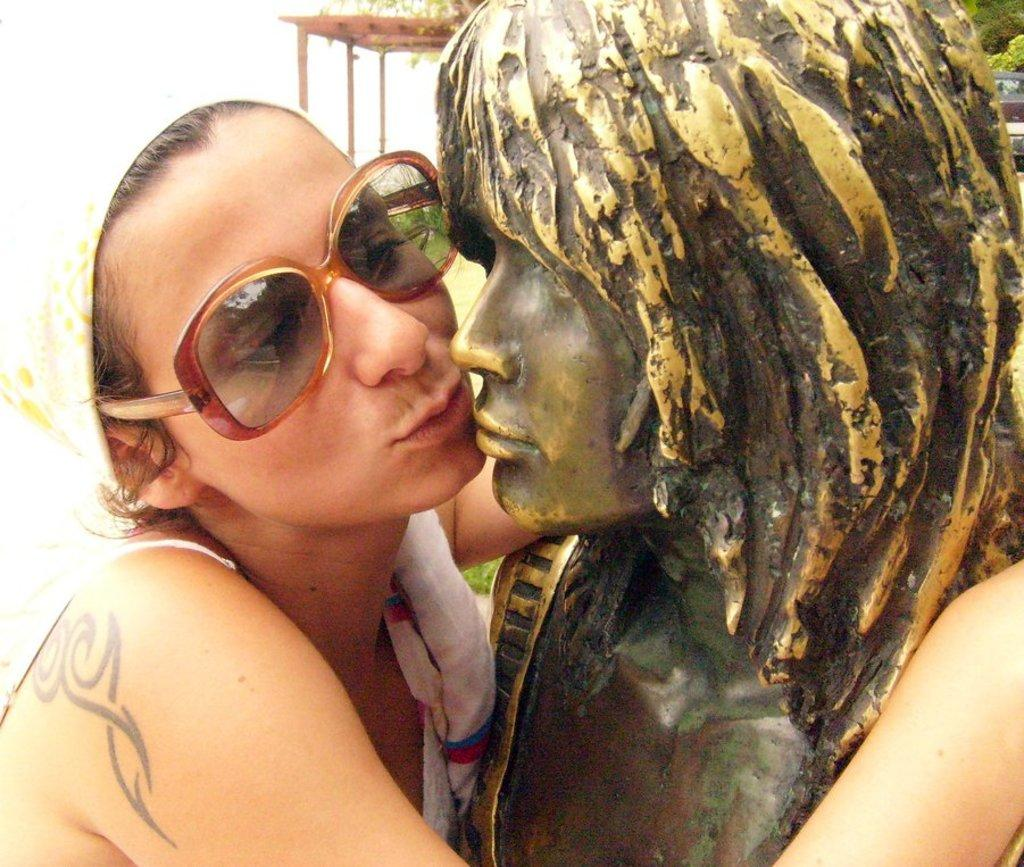Who or what is present in the image? There is a person in the image. What is the person wearing? The person is wearing goggles. What is the person holding? The person is holding a statue. What can be seen in the background of the image? There is a shed in the background of the image. What type of cable is being used by the creature in the image? There is no creature present in the image, and therefore no cable can be associated with it. 